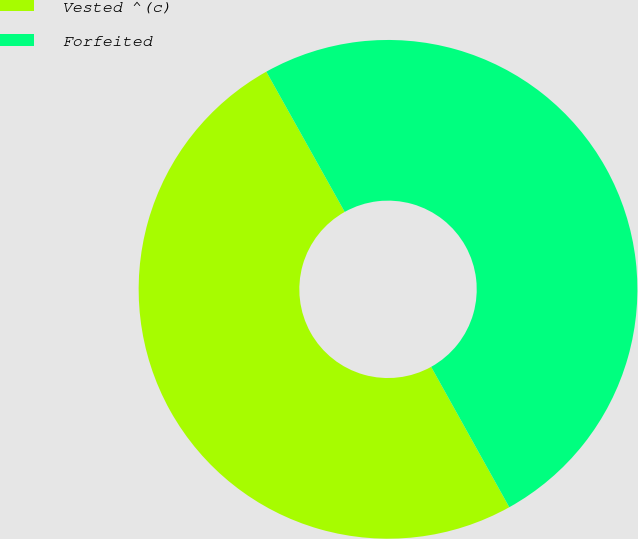<chart> <loc_0><loc_0><loc_500><loc_500><pie_chart><fcel>Vested ^(c)<fcel>Forfeited<nl><fcel>49.97%<fcel>50.03%<nl></chart> 